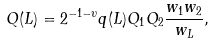Convert formula to latex. <formula><loc_0><loc_0><loc_500><loc_500>Q ( L ) = 2 ^ { - 1 - \upsilon } q ( L ) Q _ { 1 } Q _ { 2 } \frac { w _ { 1 } w _ { 2 } } { w _ { L } } ,</formula> 